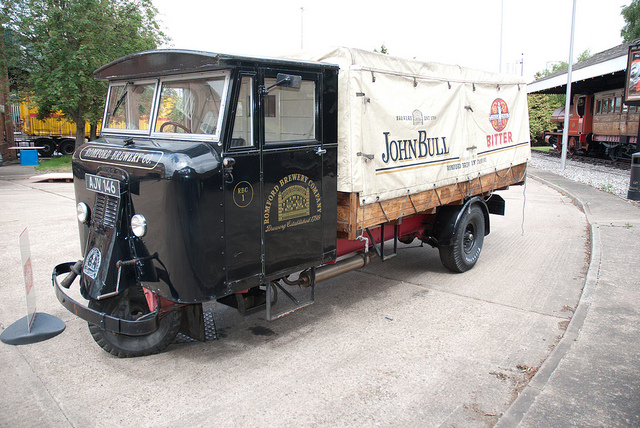Please identify all text content in this image. COMPANY JOHN BULL BITTER 